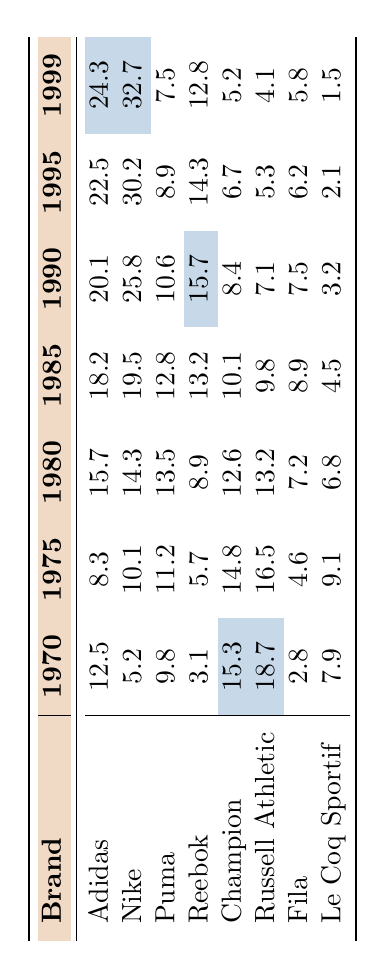What was Nike's market share in 1995? According to the table, Nike's market share in 1995 is listed as 30.2.
Answer: 30.2 Which brand had the highest market share in 1999? In the table, Adidas has the highest market share in 1999 with 24.3.
Answer: Adidas What is the average market share of Fila from 1970 to 1999? The market share values for Fila are 2.8, 4.6, 7.2, 8.9, 7.5, 6.2, and 5.8, which sums to 42.0. Dividing by 7 (the number of years), the average is 42.0 / 7 = 6.0.
Answer: 6.0 Did Puma's market share increase from 1985 to 1990? The market share for Puma in 1985 is 12.8 and in 1990 is 10.6. Since 10.6 is less than 12.8, Puma's market share did not increase during this period.
Answer: No Which two brands showed a decline in market share from 1995 to 1999? Looking at the table, both Russell Athletic and Fila's market shares decreased from 1995 to 1999 (from 5.3 to 4.1 for Russell Athletic and from 6.2 to 5.8 for Fila).
Answer: Russell Athletic and Fila What was the difference in market share between Adidas and Champion in 1980? The market share for Adidas in 1980 is 15.7, and for Champion, it is 12.6. The difference is 15.7 - 12.6 = 3.1.
Answer: 3.1 Which brand had the lowest market share in 1970? The table shows that Le Coq Sportif had the lowest market share in 1970 with a value of 7.9.
Answer: Le Coq Sportif Identify the trend of Reebok's market share from 1970 to 1999. Reebok's market share in 1970 was 3.1 and increased to 15.7 in 1990, but then declined to 12.8 in 1999. This indicates a rise followed by a decrease over these years.
Answer: Rise and then decline What was Russell Athletic's market share in 1985 and how does it compare to that in 1990? Russell Athletic's market share was 9.8 in 1985 and 7.1 in 1990. This is a decrease of 2.7.
Answer: Decrease of 2.7 Was there a year when Champion had a market share higher than 15%? Yes, Champion's market share in 1970 was 15.3, which is greater than 15%.
Answer: Yes 